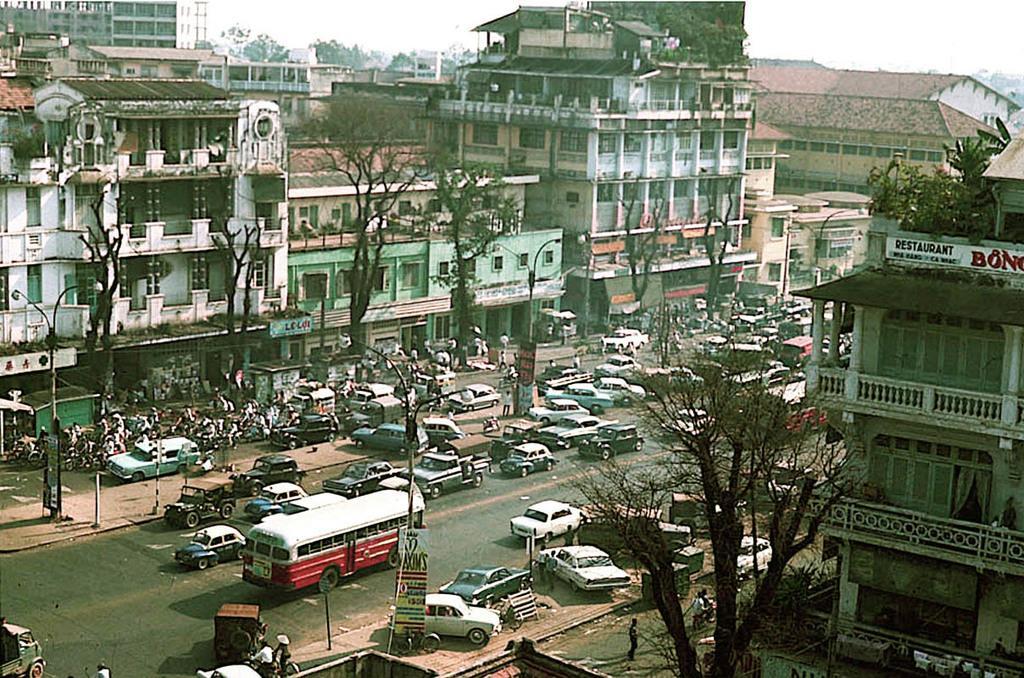Can you describe this image briefly? In the center of the image we can see vehicles on the road. On the right side of the image we can see vehicles, tree and building. On the left side of the image we can see trees, vehicles, street lights and buildings. In the background we can see buildings, trees and sky. 